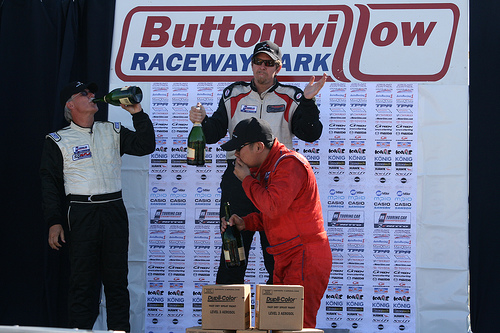<image>
Is the man to the left of the man? No. The man is not to the left of the man. From this viewpoint, they have a different horizontal relationship. Is there a box next to the wall? Yes. The box is positioned adjacent to the wall, located nearby in the same general area. 